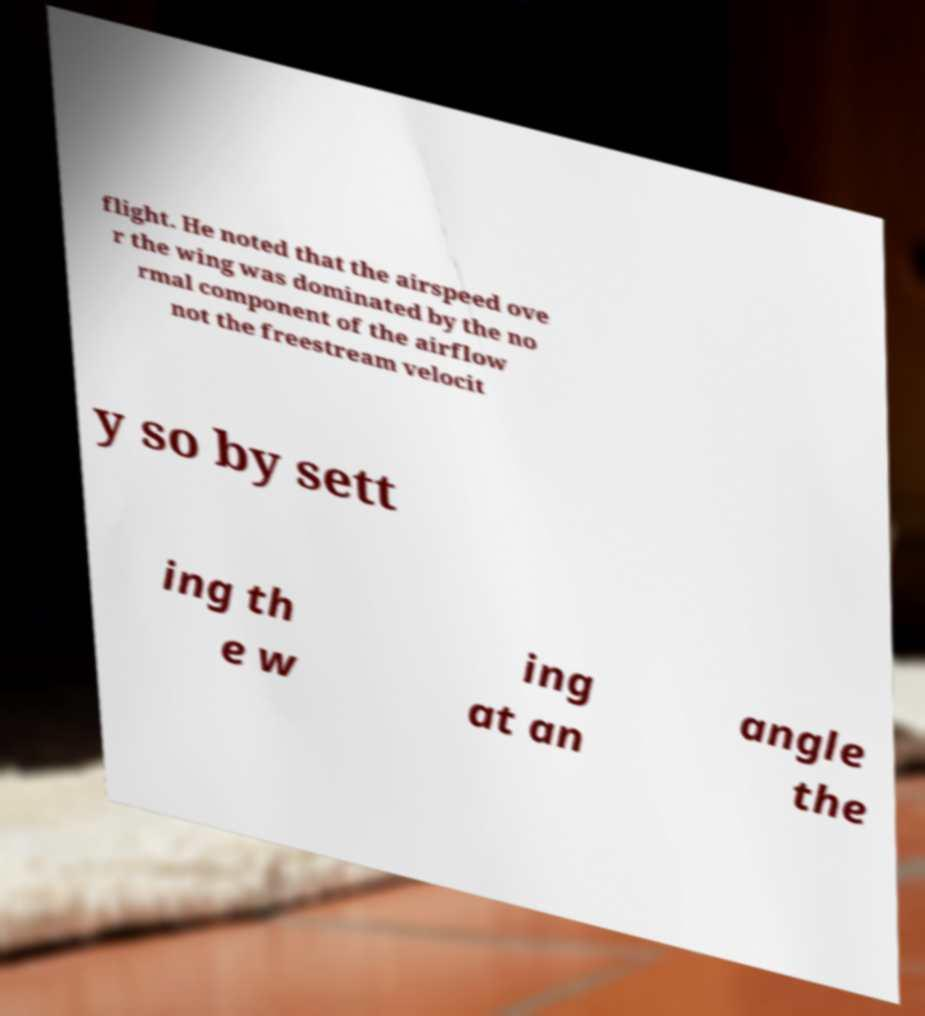What messages or text are displayed in this image? I need them in a readable, typed format. flight. He noted that the airspeed ove r the wing was dominated by the no rmal component of the airflow not the freestream velocit y so by sett ing th e w ing at an angle the 